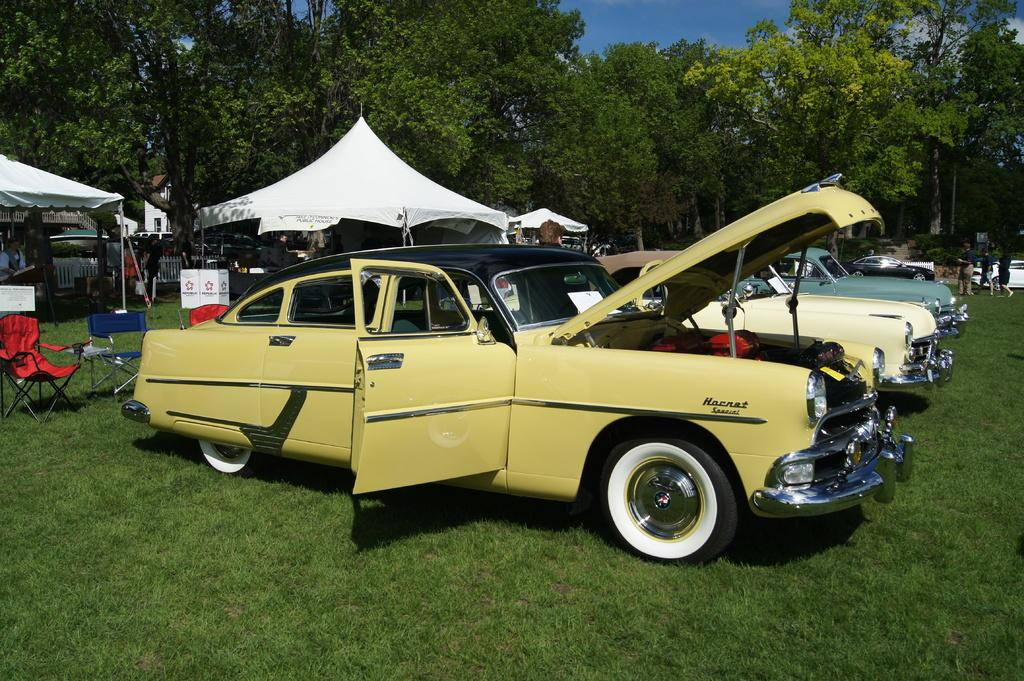What is the primary surface visible in the image? There is a ground in the image. What is located on the ground? Vehicles are present on the ground. What type of temporary shelter can be seen in the image? Tents are visible in the image. What type of seating is available in the image? Chairs are present in the image. What is visible at the top of the image? The sky is visible at the top of the image. How many persons can be seen on the right side of the image? There are three persons on the right side of the image. What type of religious ceremony is taking place in the image? There is no indication of a religious ceremony in the image; it features a ground with vehicles, tents, chairs, and persons. What type of waste is visible in the image? There is no waste visible in the image; it features a ground with vehicles, tents, chairs, and persons. 